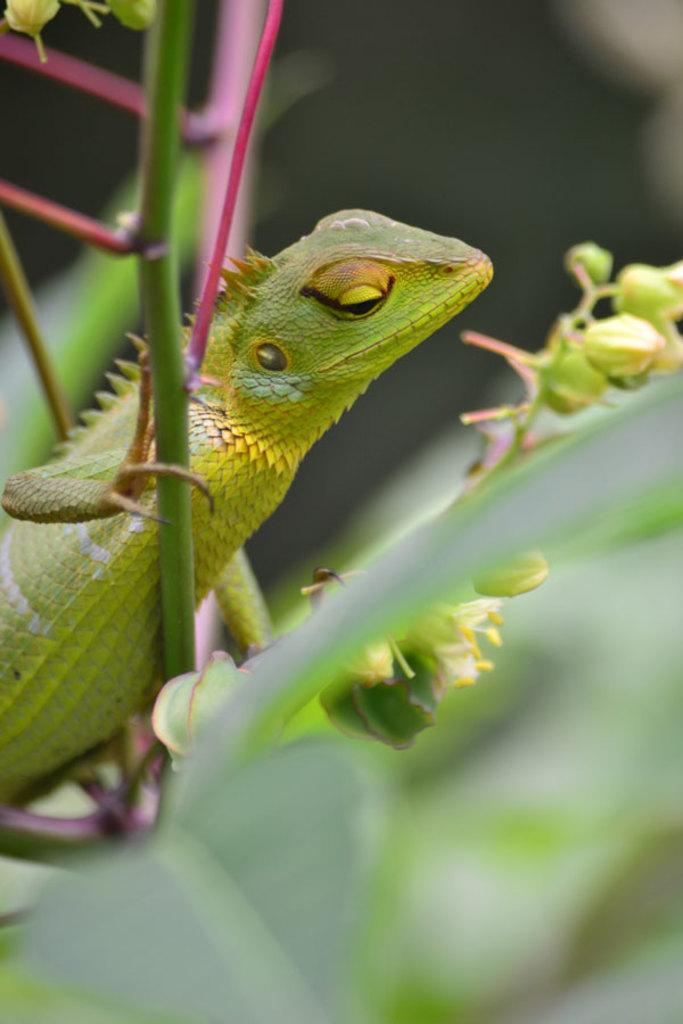What type of animal is in the image? There is a green anole in the image. Where is the green anole located? The green anole is on a plant. Can you describe the background of the image? The background of the image is blurred. What type of cracker is the green anole holding in the image? There is no cracker present in the image, and the green anole is not holding anything. Can you tell me how many leather shoes are visible in the image? There are no leather shoes present in the image. 